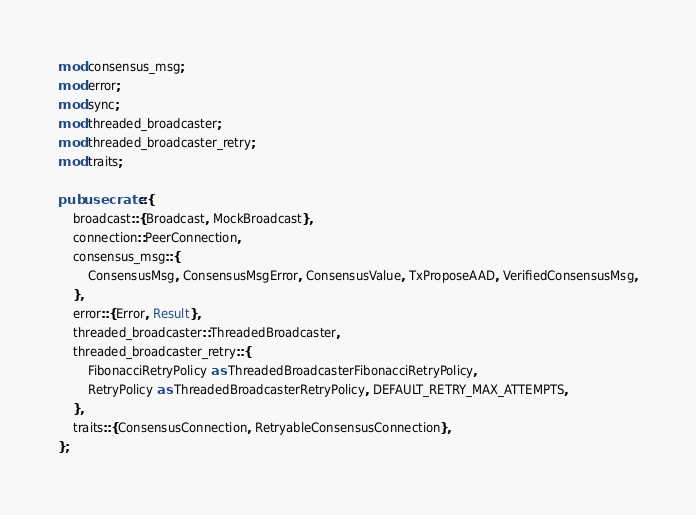<code> <loc_0><loc_0><loc_500><loc_500><_Rust_>mod consensus_msg;
mod error;
mod sync;
mod threaded_broadcaster;
mod threaded_broadcaster_retry;
mod traits;

pub use crate::{
    broadcast::{Broadcast, MockBroadcast},
    connection::PeerConnection,
    consensus_msg::{
        ConsensusMsg, ConsensusMsgError, ConsensusValue, TxProposeAAD, VerifiedConsensusMsg,
    },
    error::{Error, Result},
    threaded_broadcaster::ThreadedBroadcaster,
    threaded_broadcaster_retry::{
        FibonacciRetryPolicy as ThreadedBroadcasterFibonacciRetryPolicy,
        RetryPolicy as ThreadedBroadcasterRetryPolicy, DEFAULT_RETRY_MAX_ATTEMPTS,
    },
    traits::{ConsensusConnection, RetryableConsensusConnection},
};
</code> 